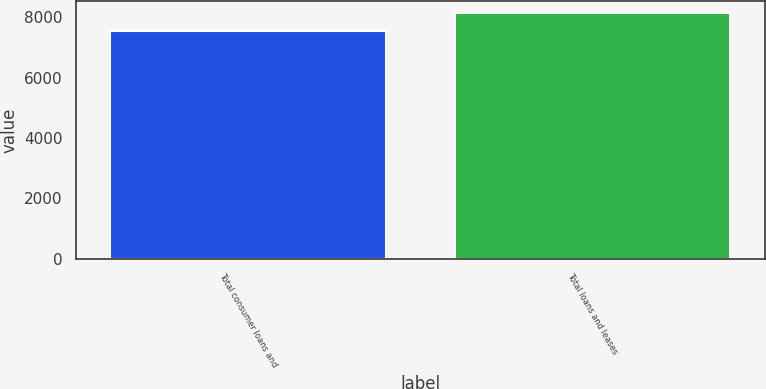Convert chart to OTSL. <chart><loc_0><loc_0><loc_500><loc_500><bar_chart><fcel>Total consumer loans and<fcel>Total loans and leases<nl><fcel>7545<fcel>8134<nl></chart> 